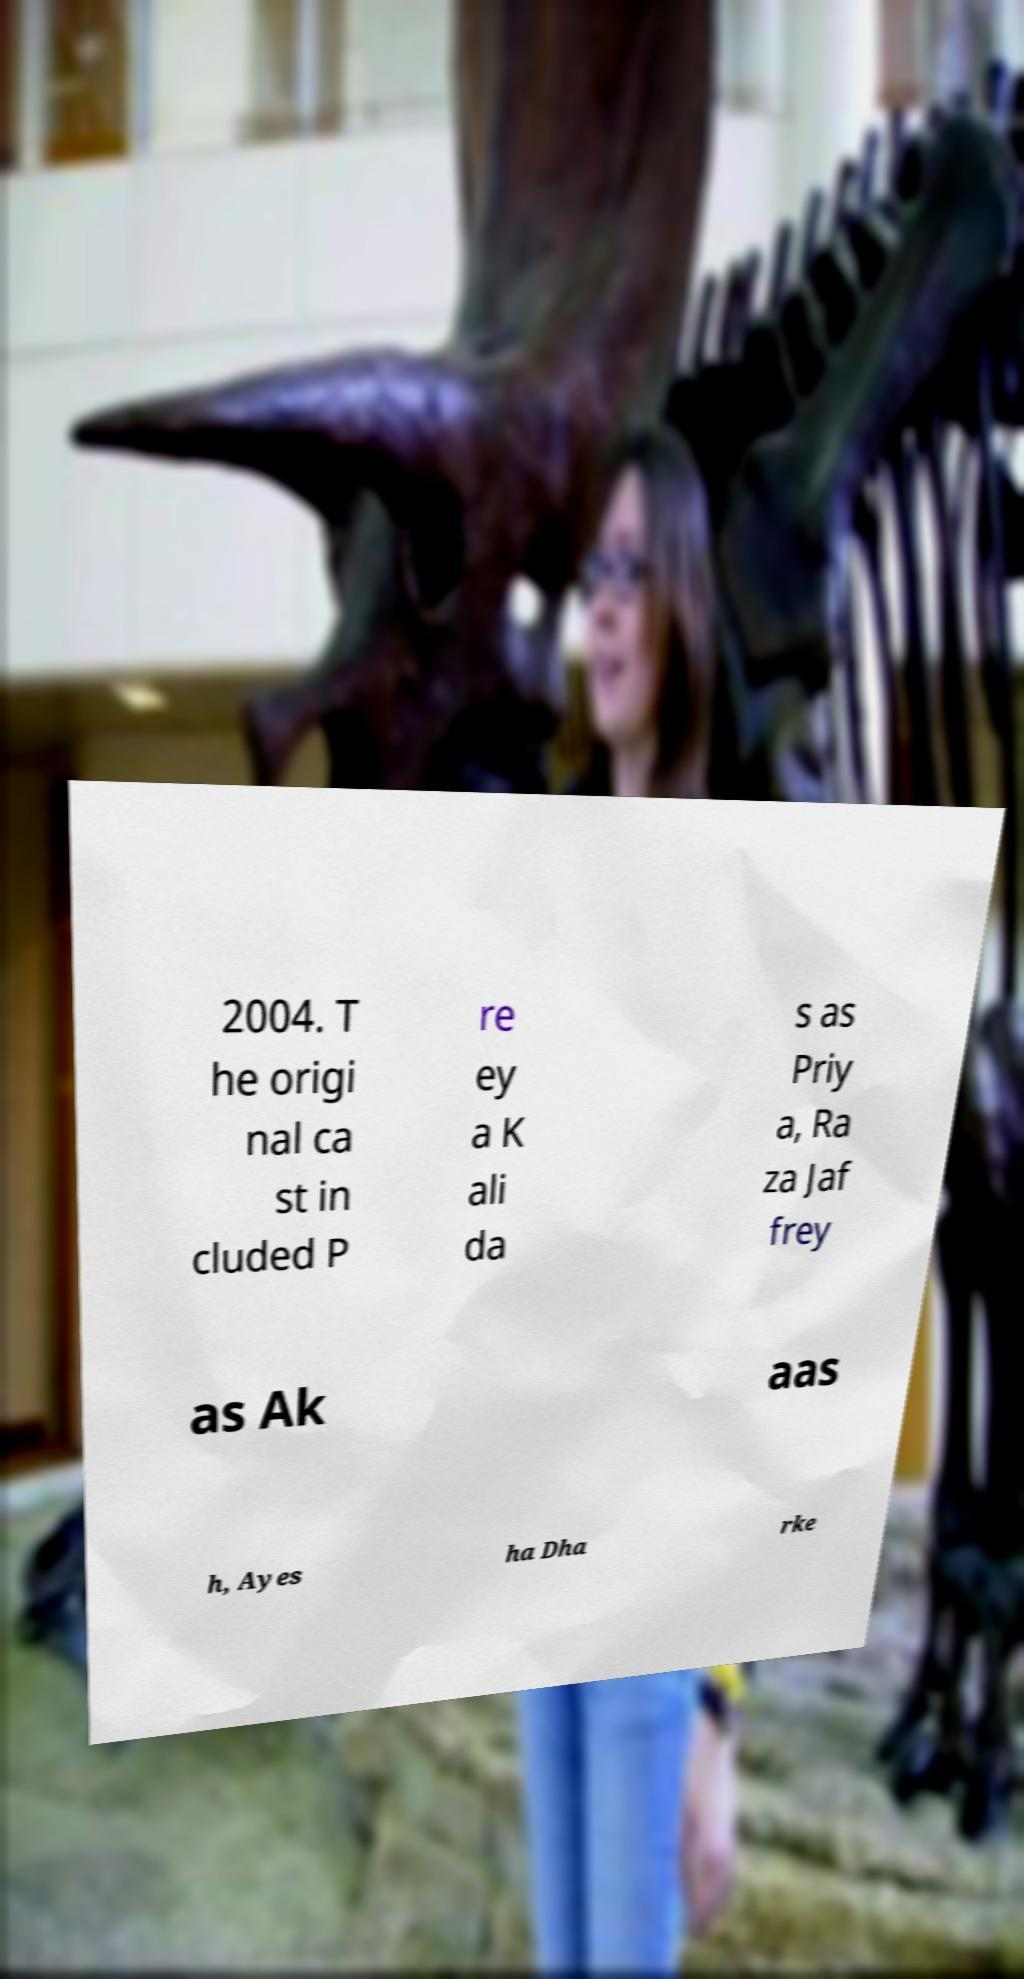Please read and relay the text visible in this image. What does it say? 2004. T he origi nal ca st in cluded P re ey a K ali da s as Priy a, Ra za Jaf frey as Ak aas h, Ayes ha Dha rke 